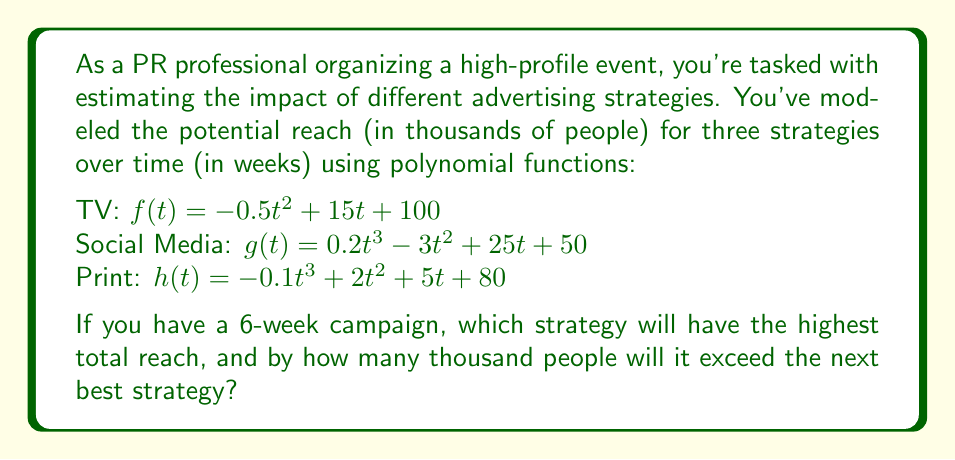Provide a solution to this math problem. To solve this problem, we need to follow these steps:

1. Calculate the total reach for each strategy over 6 weeks.
2. Compare the results to find the highest reach.
3. Calculate the difference between the top two strategies.

Step 1: Calculate total reach

For each strategy, we need to sum the reach from week 0 to week 5 (6 weeks total).

TV: $\sum_{t=0}^5 f(t) = \sum_{t=0}^5 (-0.5t^2 + 15t + 100)$
Social Media: $\sum_{t=0}^5 g(t) = \sum_{t=0}^5 (0.2t^3 - 3t^2 + 25t + 50)$
Print: $\sum_{t=0}^5 h(t) = \sum_{t=0}^5 (-0.1t^3 + 2t^2 + 5t + 80)$

Calculating each sum:

TV: 100 + 114.5 + 118 + 110.5 + 92 + 62.5 = 597.5
Social Media: 50 + 72.2 + 94.8 + 128.2 + 183.8 + 273.0 = 802.0
Print: 80 + 86.9 + 93.6 + 99.1 + 102.4 + 102.5 = 564.5

Step 2: Compare results

Social Media has the highest reach at 802.0 thousand people.

Step 3: Calculate the difference

The next best strategy is TV with 597.5 thousand people.
Difference: 802.0 - 597.5 = 204.5 thousand people
Answer: Social Media; 204.5 thousand 